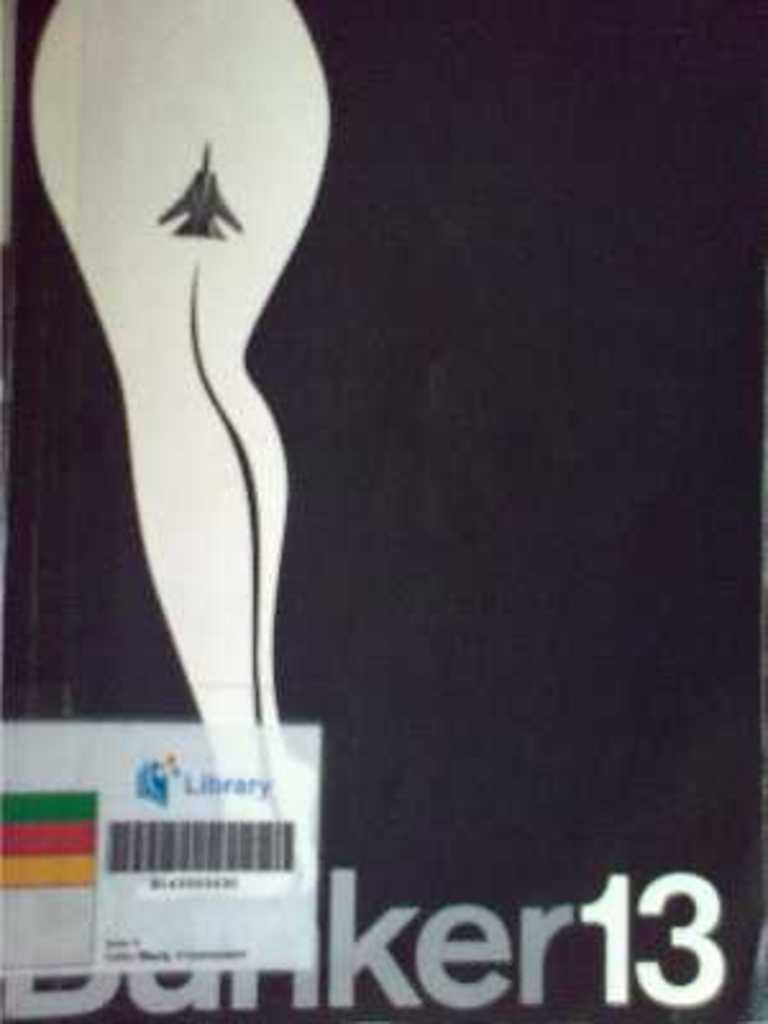<image>
Describe the image concisely. A box or book that says Banker 13 with a library code strip on it. 